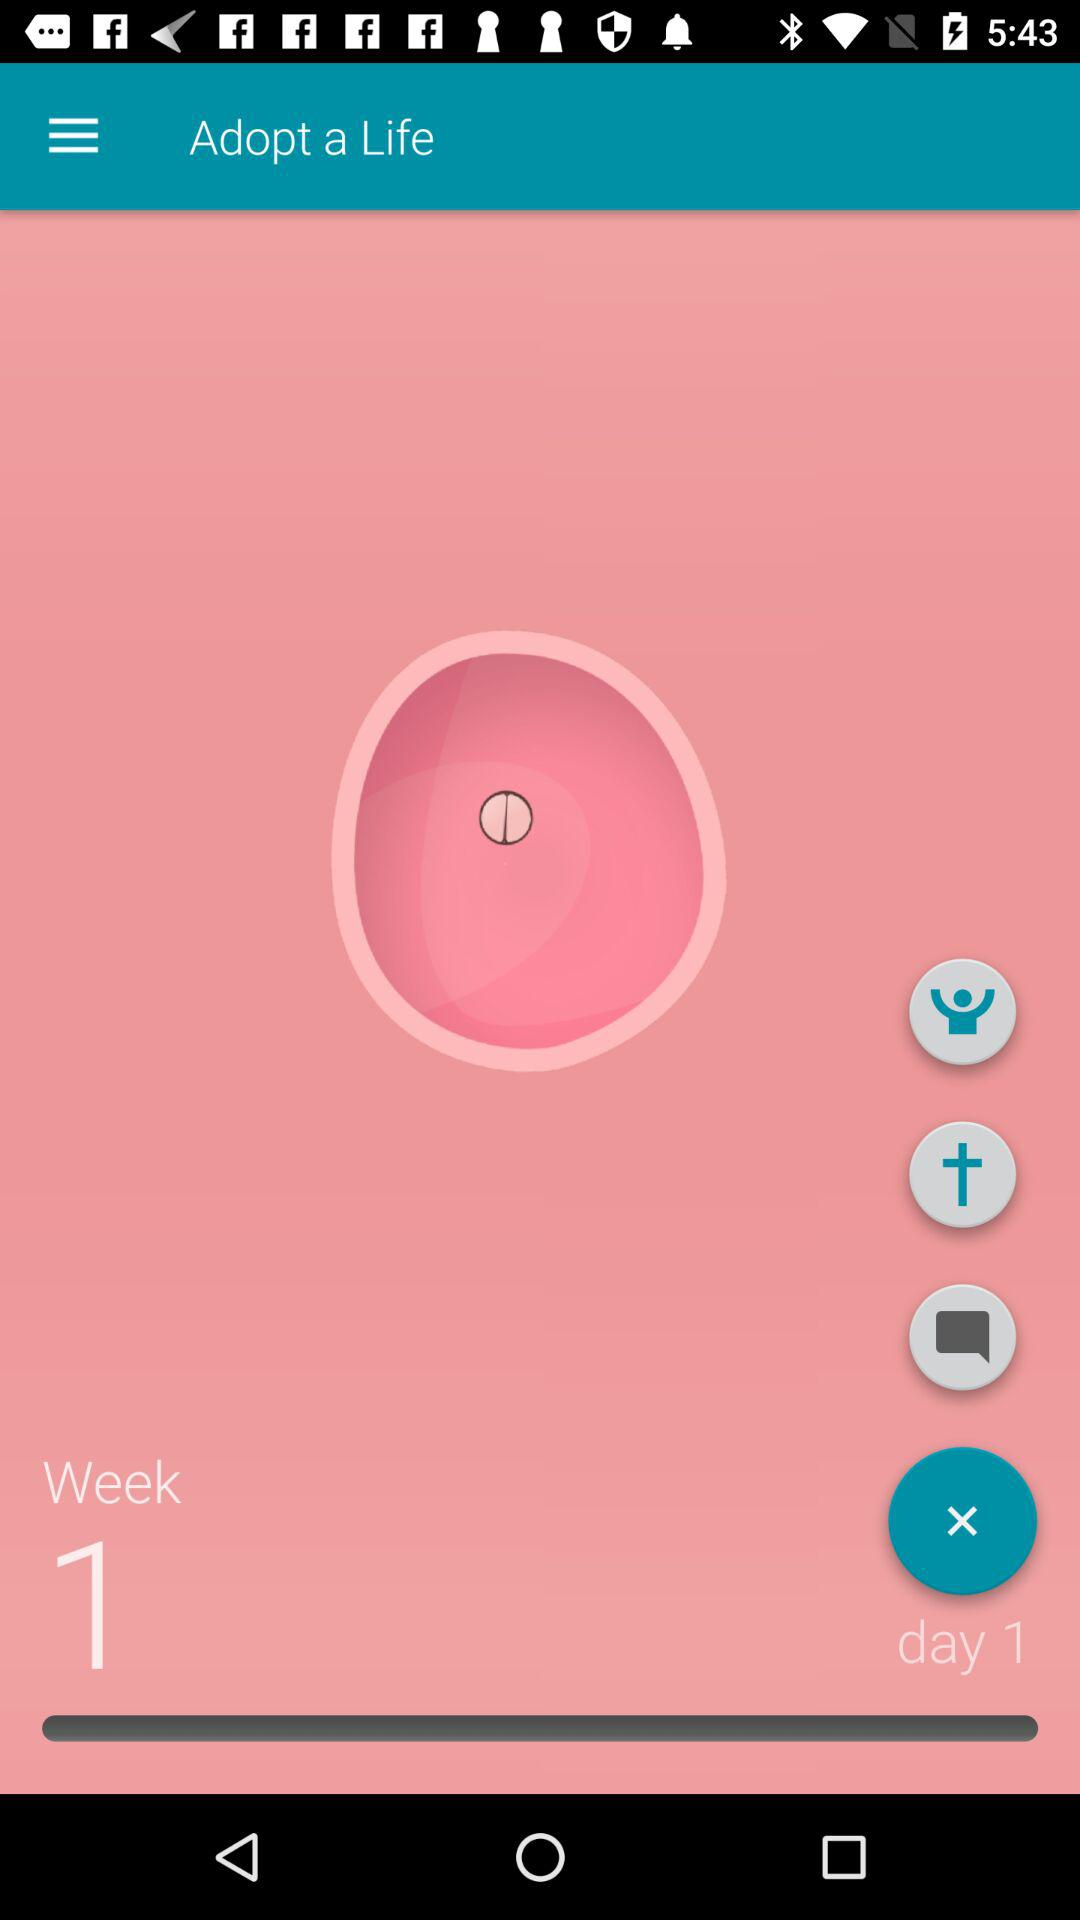How many more pink circles are there with a black circle in the middle than with a circle in the middle?
Answer the question using a single word or phrase. 1 